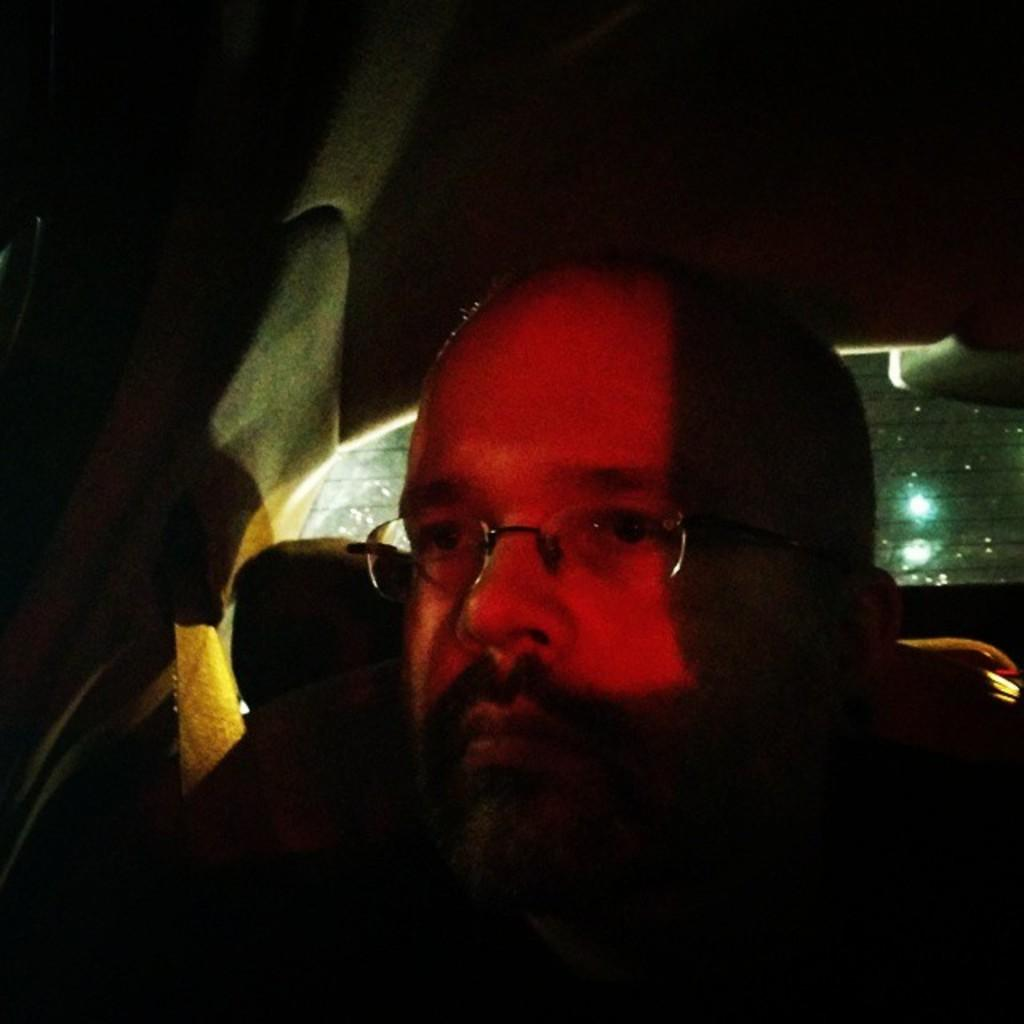Who is the main subject in the image? There is a man in the image. Where is the man located in the image? The man is in the center of the image. What else can be seen in the image besides the man? There is a car in the image. What type of coal is being used to fuel the car in the image? There is no coal present in the image, and the car's fuel source is not mentioned. How many grapes can be seen hanging from the man's hat in the image? There are no grapes or hats present in the image. 